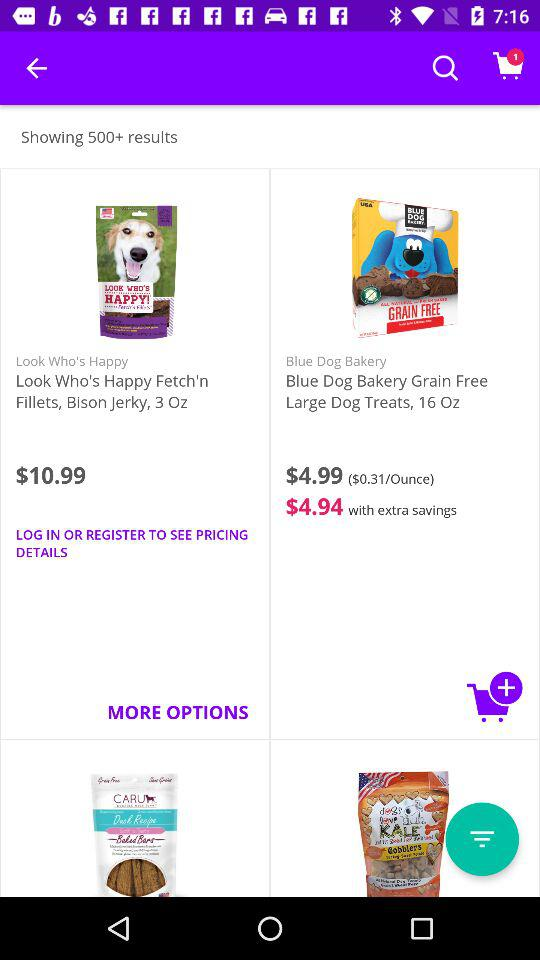How many items are in the cart? There is 1 item in the cart. 